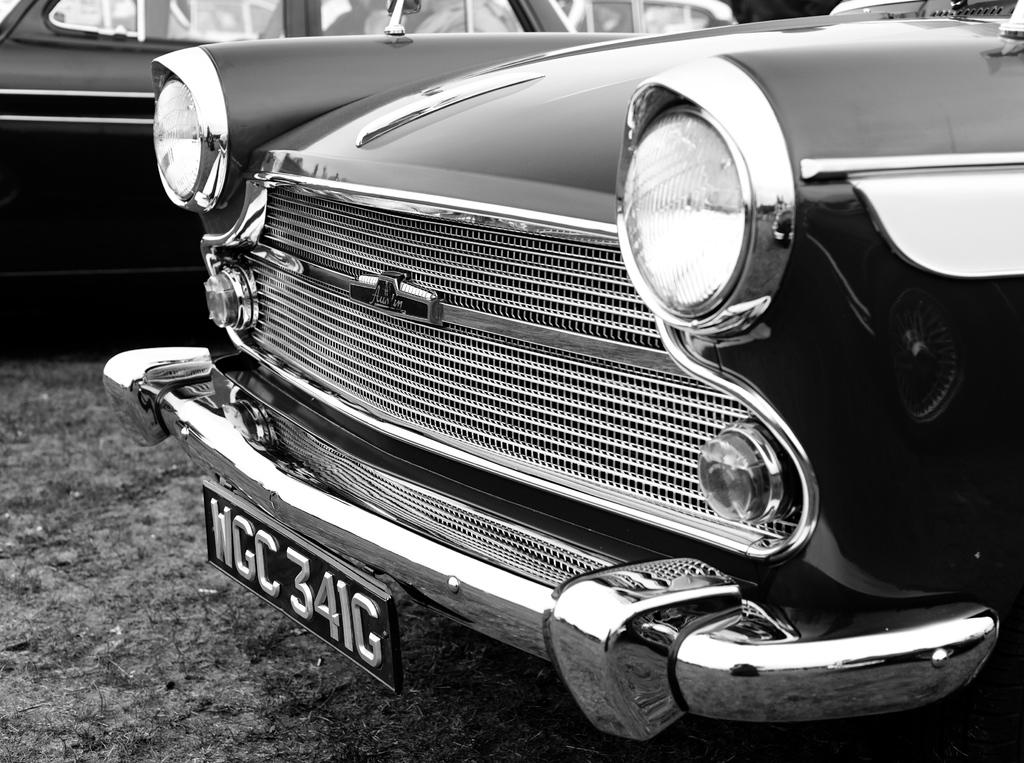What is the color scheme of the image? The image is black and white. What type of vehicle can be seen in the image? There is a car with a registration plate in the image. Are there any other vehicles visible in the image? Yes, there is another car visible in the image. What type of rice is being served in the image? There is no rice present in the image; it features two cars. How many clover leaves can be seen on the registration plate of the car? The registration plate does not have any clover leaves; it only contains letters and numbers. 